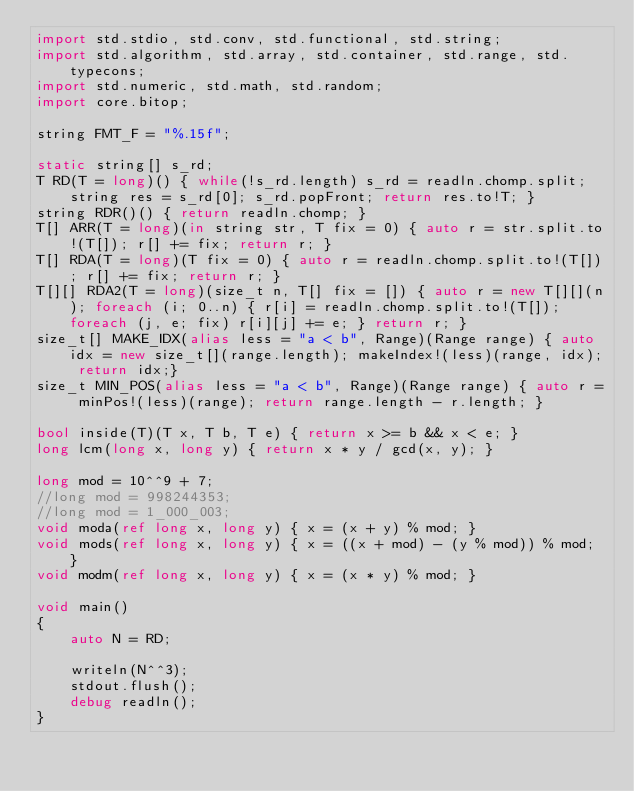<code> <loc_0><loc_0><loc_500><loc_500><_D_>import std.stdio, std.conv, std.functional, std.string;
import std.algorithm, std.array, std.container, std.range, std.typecons;
import std.numeric, std.math, std.random;
import core.bitop;

string FMT_F = "%.15f";

static string[] s_rd;
T RD(T = long)() { while(!s_rd.length) s_rd = readln.chomp.split; string res = s_rd[0]; s_rd.popFront; return res.to!T; }
string RDR()() { return readln.chomp; }
T[] ARR(T = long)(in string str, T fix = 0) { auto r = str.split.to!(T[]); r[] += fix; return r; }
T[] RDA(T = long)(T fix = 0) { auto r = readln.chomp.split.to!(T[]); r[] += fix; return r; }
T[][] RDA2(T = long)(size_t n, T[] fix = []) { auto r = new T[][](n); foreach (i; 0..n) { r[i] = readln.chomp.split.to!(T[]); foreach (j, e; fix) r[i][j] += e; } return r; }
size_t[] MAKE_IDX(alias less = "a < b", Range)(Range range) { auto idx = new size_t[](range.length); makeIndex!(less)(range, idx); return idx;}
size_t MIN_POS(alias less = "a < b", Range)(Range range) { auto r = minPos!(less)(range); return range.length - r.length; }

bool inside(T)(T x, T b, T e) { return x >= b && x < e; }
long lcm(long x, long y) { return x * y / gcd(x, y); }

long mod = 10^^9 + 7;
//long mod = 998244353;
//long mod = 1_000_003;
void moda(ref long x, long y) { x = (x + y) % mod; }
void mods(ref long x, long y) { x = ((x + mod) - (y % mod)) % mod; }
void modm(ref long x, long y) { x = (x * y) % mod; }

void main()
{
	auto N = RD;

	writeln(N^^3);
	stdout.flush();
	debug readln();
}</code> 